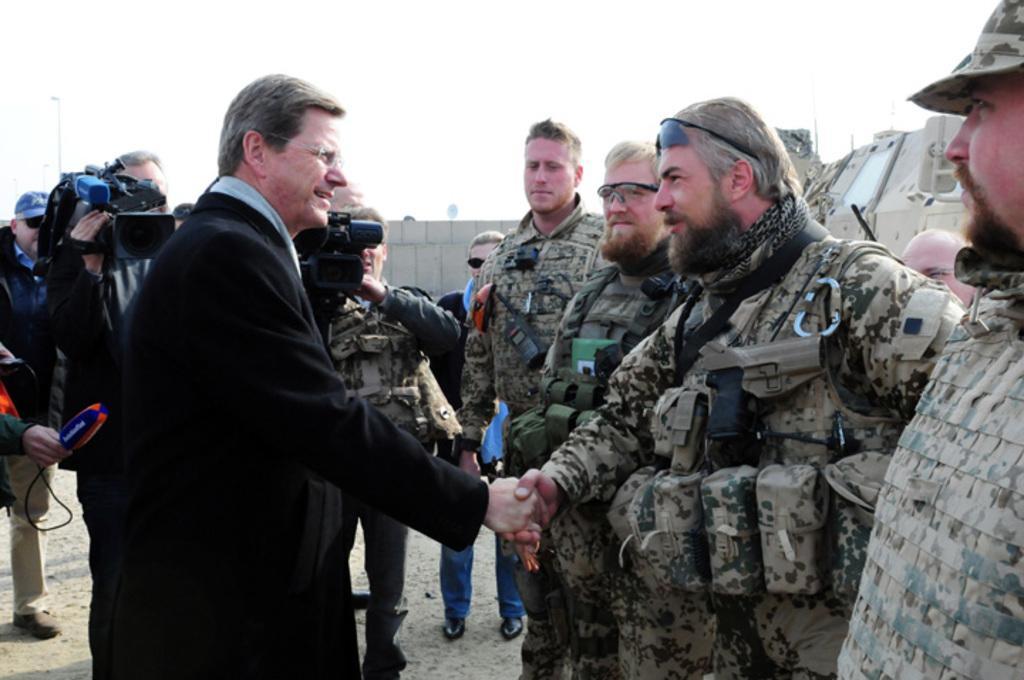Describe this image in one or two sentences. In this image there are a few people standing and few are holding cameras and mics in their hand, there are two people shake hands to each other. In the background there is a wall and the sky. On the right side of the image its look like a vehicle. 